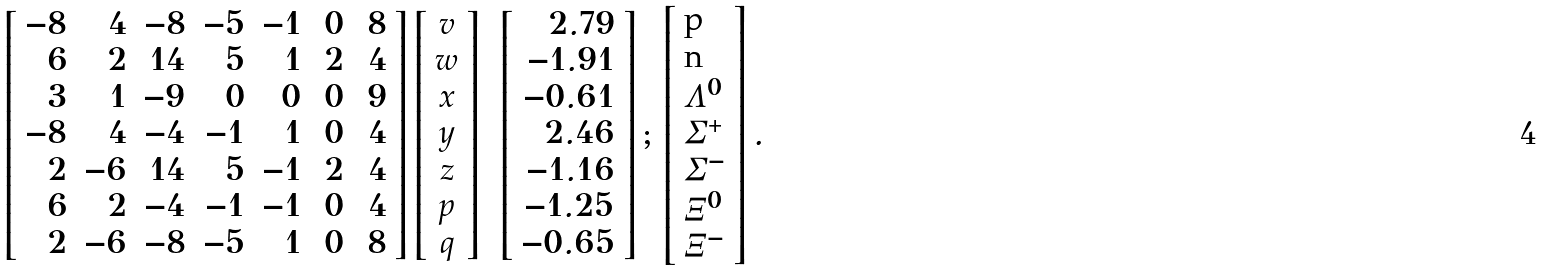<formula> <loc_0><loc_0><loc_500><loc_500>\left [ \begin{array} { r r r r r r r } - 8 & 4 & - 8 & - 5 & - 1 & \, 0 & \, 8 \\ 6 & 2 & 1 4 & 5 & 1 & 2 & 4 \\ 3 & 1 & - 9 & 0 & 0 & 0 & 9 \\ - 8 & 4 & - 4 & - 1 & 1 & 0 & 4 \\ 2 & - 6 & 1 4 & 5 & - 1 & 2 & 4 \\ 6 & 2 & - 4 & - 1 & - 1 & 0 & 4 \\ 2 & - 6 & - 8 & - 5 & 1 & 0 & 8 \end{array} \right ] \left [ \begin{array} { c } v \\ w \\ x \\ y \\ z \\ p \\ q \end{array} \right ] = \left [ \begin{array} { r } 2 . 7 9 \\ - 1 . 9 1 \\ - 0 . 6 1 \\ 2 . 4 6 \\ - 1 . 1 6 \\ - 1 . 2 5 \\ - 0 . 6 5 \end{array} \right ] ; \, \left [ \begin{array} { l } \text {p} \\ \text {n} \\ \Lambda ^ { 0 } \\ \Sigma ^ { + } \\ \Sigma ^ { - } \\ \Xi ^ { 0 } \\ \Xi ^ { - } \end{array} \right ] .</formula> 